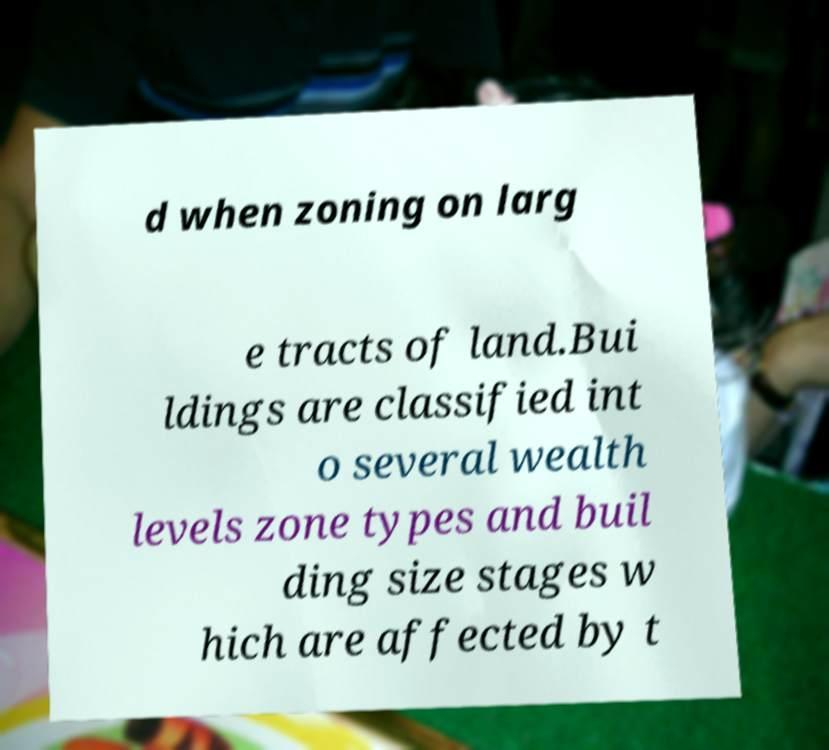Can you accurately transcribe the text from the provided image for me? d when zoning on larg e tracts of land.Bui ldings are classified int o several wealth levels zone types and buil ding size stages w hich are affected by t 